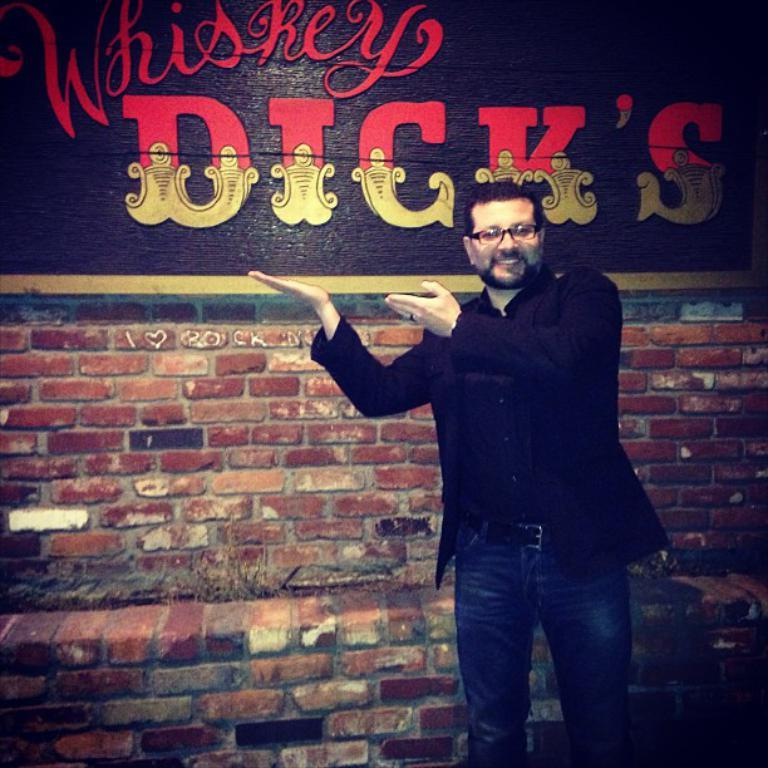What is the person in the image doing? The person is standing in the image and smiling. What can be seen on the board in the image? There is text on the board in the image. What other text is visible in the image? There is text on a brick wall in the image. What color is the brain that is being pushed through the channel in the image? There is no brain or channel present in the image. 